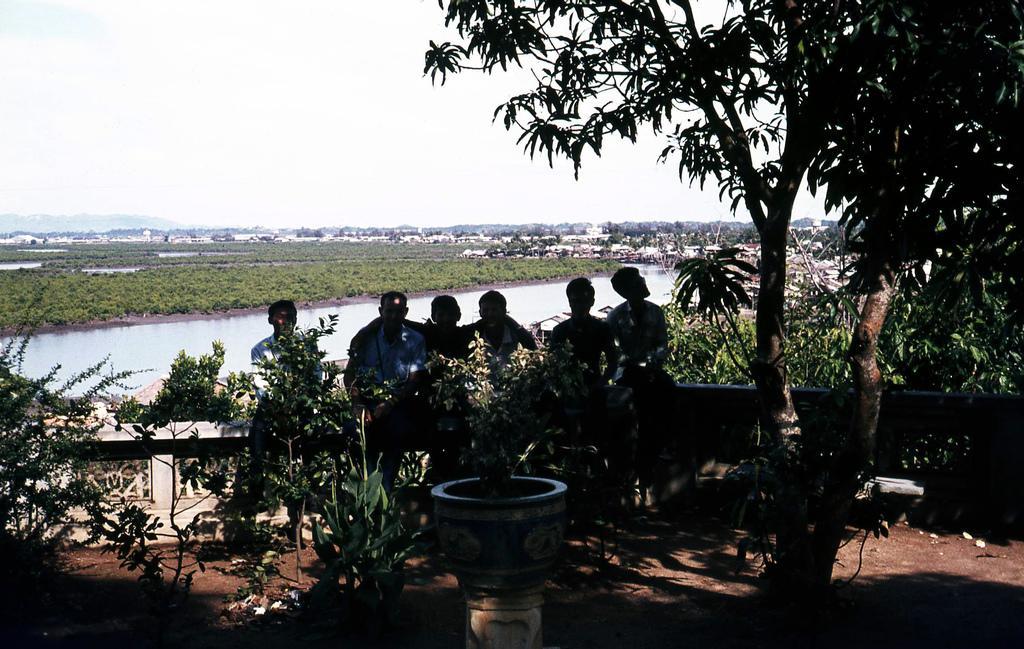How would you summarize this image in a sentence or two? In this picture there are men in the center of the image and there are trees on the right and left side of the image, there is water in the center of the image. 